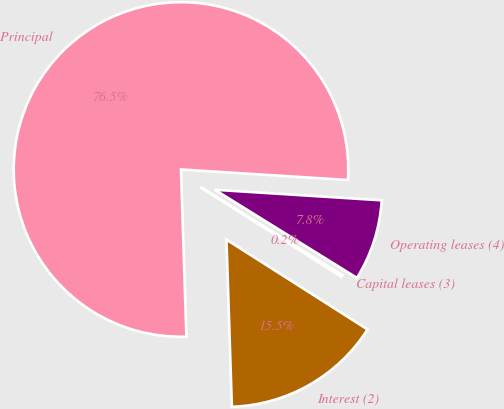<chart> <loc_0><loc_0><loc_500><loc_500><pie_chart><fcel>Principal<fcel>Interest (2)<fcel>Capital leases (3)<fcel>Operating leases (4)<nl><fcel>76.52%<fcel>15.46%<fcel>0.19%<fcel>7.83%<nl></chart> 